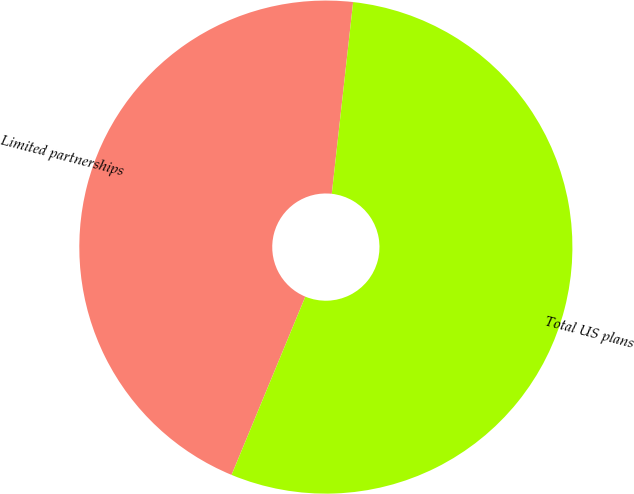Convert chart. <chart><loc_0><loc_0><loc_500><loc_500><pie_chart><fcel>Limited partnerships<fcel>Total US plans<nl><fcel>45.52%<fcel>54.48%<nl></chart> 